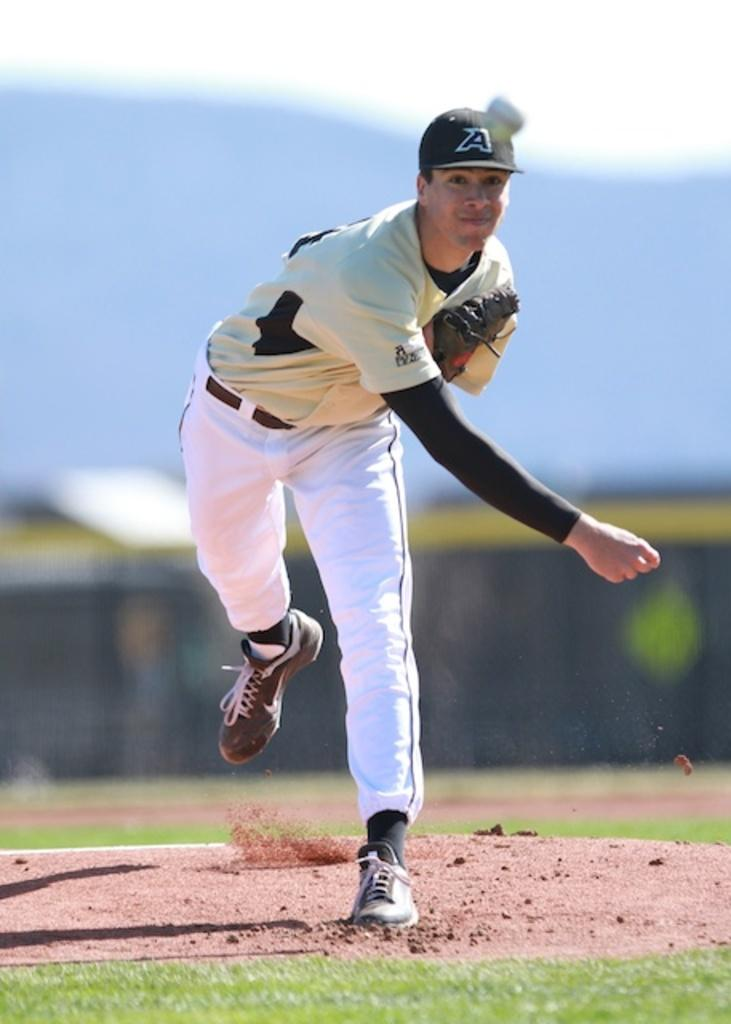<image>
Describe the image concisely. the letter A is on the hat of the person 